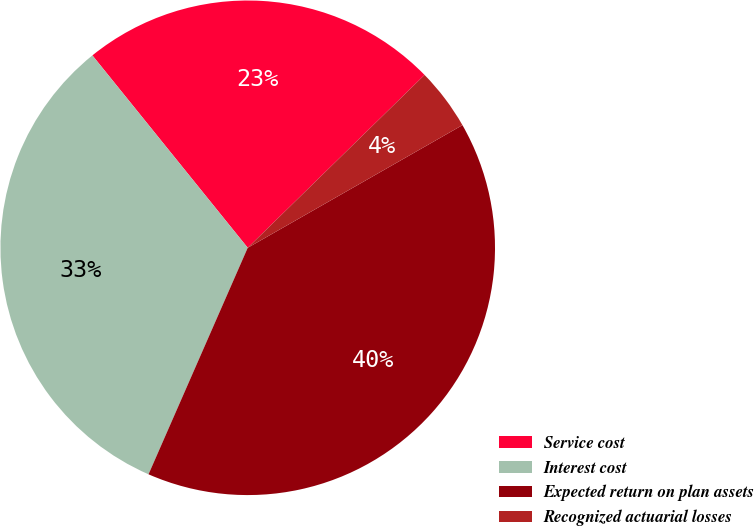<chart> <loc_0><loc_0><loc_500><loc_500><pie_chart><fcel>Service cost<fcel>Interest cost<fcel>Expected return on plan assets<fcel>Recognized actuarial losses<nl><fcel>23.49%<fcel>32.62%<fcel>39.83%<fcel>4.06%<nl></chart> 